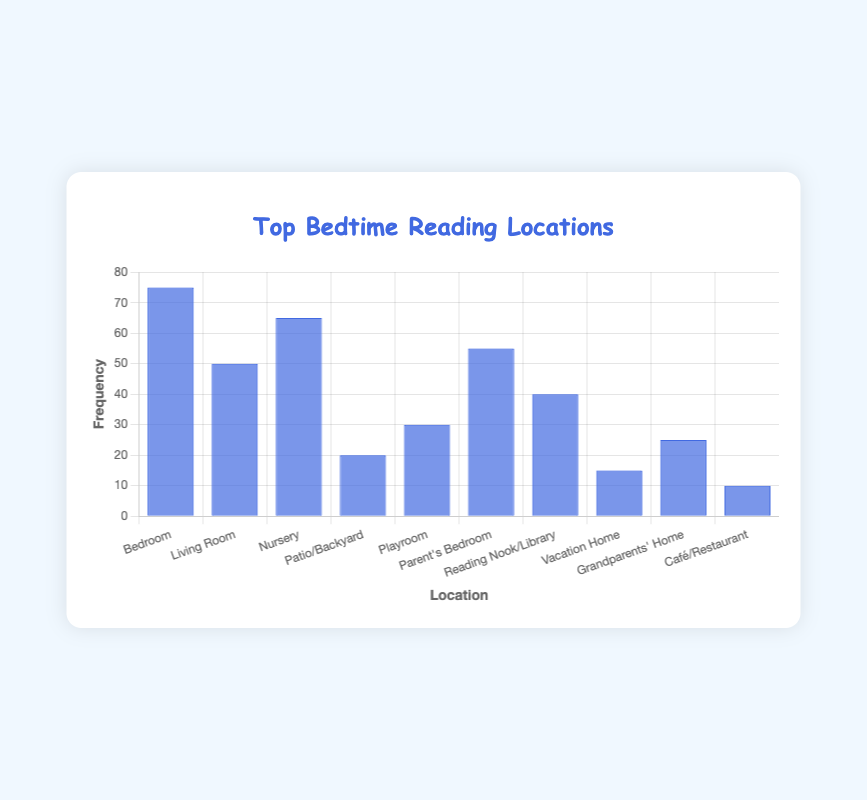Which location has the highest frequency for bedtime reading? The chart shows the frequencies for each location. The highest bar corresponds to the "Bedroom" with a frequency of 75.
Answer: Bedroom Which location has the lowest frequency? The lowest bar represents the "Café/Restaurant" with a frequency of 10.
Answer: Café/Restaurant What is the total frequency of bedtime reading in the "Bedroom" and "Living Room" combined? Add the frequencies of "Bedroom" (75) and "Living Room" (50). 75 + 50 = 125.
Answer: 125 How much more frequent is bedtime reading in the "Nursery" compared to the "Patio/Backyard"? Subtract the frequency of "Patio/Backyard" (20) from the "Nursery" (65). 65 - 20 = 45.
Answer: 45 What is the average frequency of bedtime reading across all locations? Add all the frequencies and divide by the number of locations. (75 + 50 + 65 + 20 + 30 + 55 + 40 + 15 + 25 + 10) / 10 = 38.5.
Answer: 38.5 Which three locations have the highest frequencies? Identify the three tallest bars corresponding to "Bedroom" (75), "Nursery" (65), and "Parent's Bedroom" (55).
Answer: Bedroom, Nursery, Parent's Bedroom How much less frequently is bedtime reading in "Grandparents' Home" compared to "Living Room"? Subtract the frequency of "Grandparents' Home" (25) from "Living Room" (50). 50 - 25 = 25.
Answer: 25 Which locations have a frequency of 40 or more? Identify bars with a height of 40 or above: "Bedroom" (75), "Living Room" (50), "Nursery" (65), "Parent's Bedroom" (55), "Reading Nook/Library" (40).
Answer: Bedroom, Living Room, Nursery, Parent's Bedroom, Reading Nook/Library 